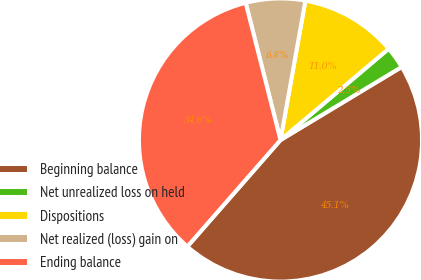Convert chart to OTSL. <chart><loc_0><loc_0><loc_500><loc_500><pie_chart><fcel>Beginning balance<fcel>Net unrealized loss on held<fcel>Dispositions<fcel>Net realized (loss) gain on<fcel>Ending balance<nl><fcel>45.07%<fcel>2.52%<fcel>11.03%<fcel>6.77%<fcel>34.61%<nl></chart> 